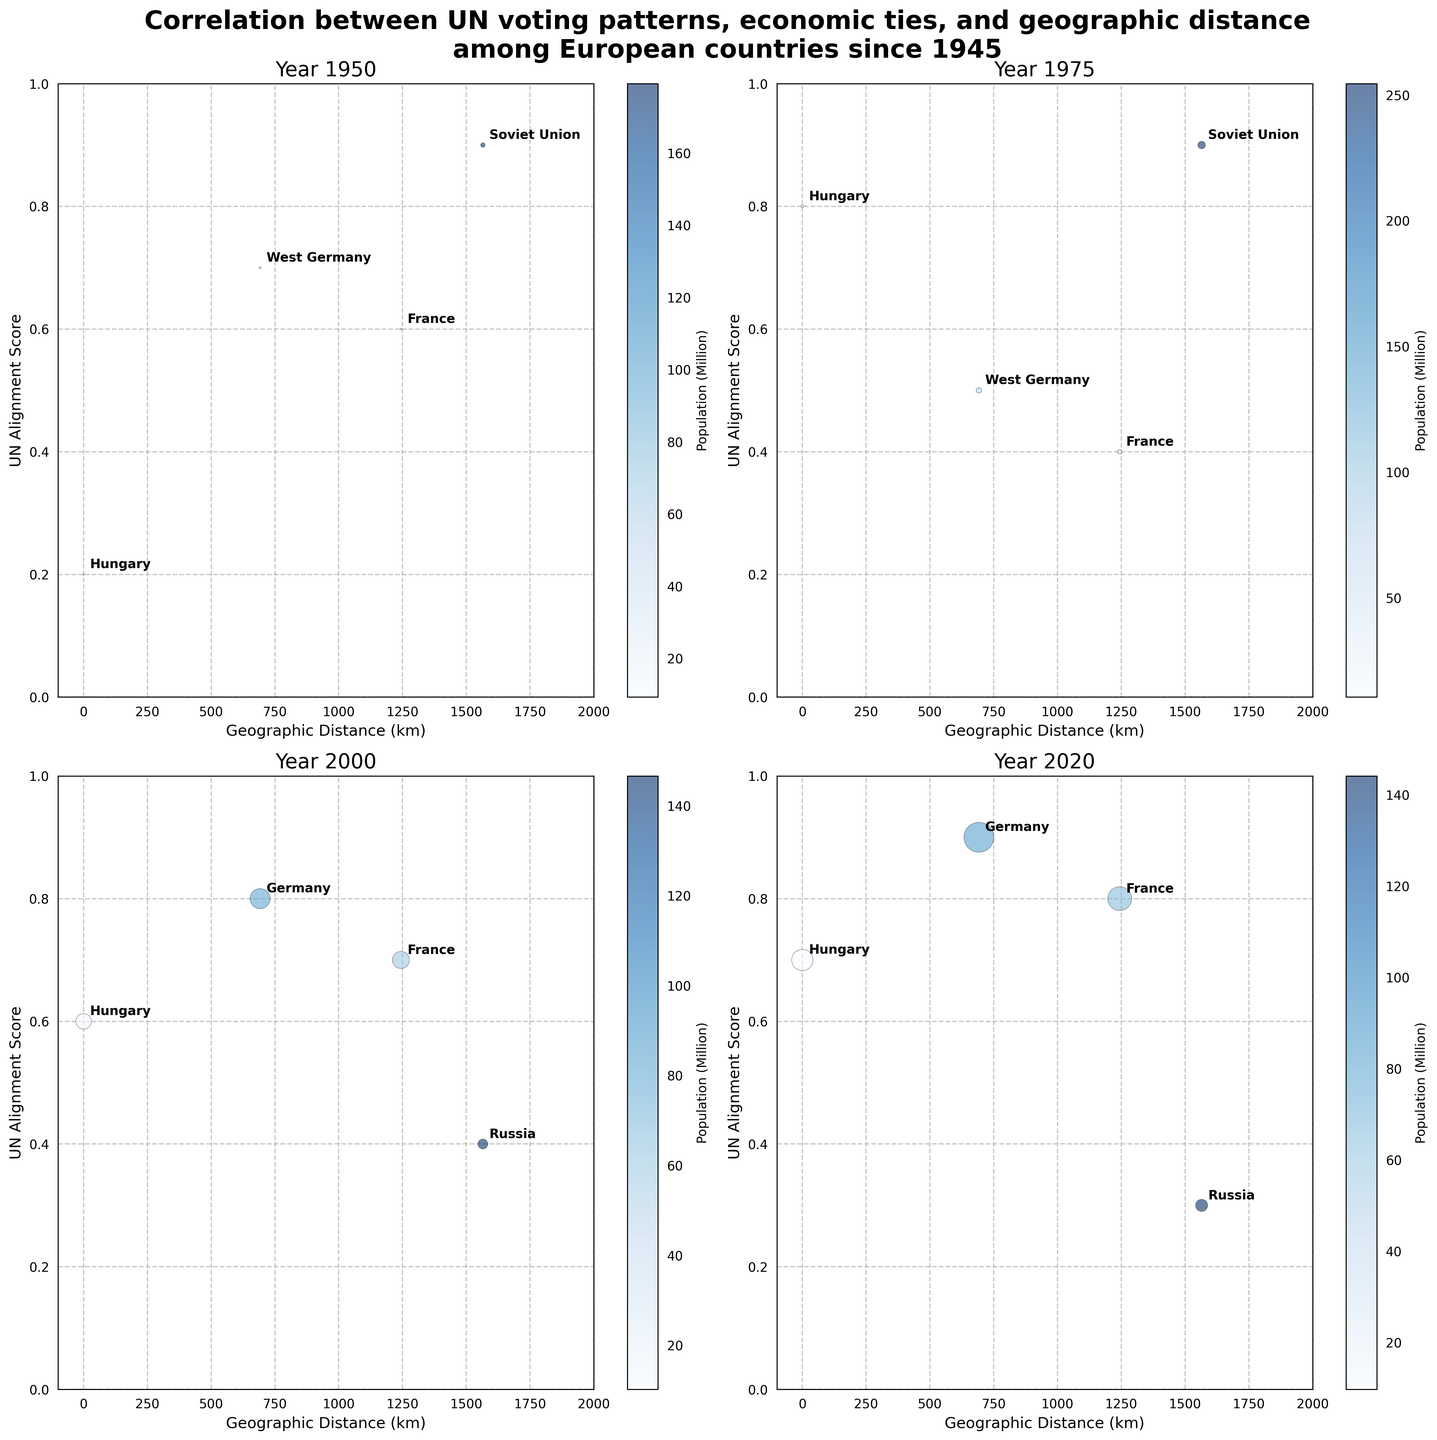Which countries have a geographic distance of 0 km in the year 1950? By observing the subplot for the year 1950, you can identify which countries have markers at the geographic distance of 0 km. In 1950, the country with a distance of 0 km is Hungary.
Answer: Hungary What is the title of the figure? The title is usually prominently displayed at the top of the figure and it describes the overall theme of the plotted data.
Answer: Correlation between UN voting patterns, economic ties, and geographic distance among European countries since 1945 Which year shows the highest UN Alignment Score for Germany? To find the highest UN Alignment Score for Germany, check the subplots for all the years and compare the scores for Germany in each year. In the year 2020, Germany has the highest UN Alignment Score of 0.9.
Answer: 2020 How does the trade volume for France change from 1950 to 2020? Compare the sizes of the bubbles for France in the subplots for the years 1950 and 2020 respectively. In 1950, France has a trade volume of 180 million EUR, and in 2020, a trade volume of 35000 million EUR. The trade volume has increased significantly over this period.
Answer: Increased significantly Which country has the largest bubble in the year 2000? The size of the bubbles represents the trade volume, and the largest bubble indicates the highest trade volume. In the year 2000, Germany has the largest bubble.
Answer: Germany What trend can be observed in the UN Alignment Score of Hungary from 1950 to 2020? Observe the position of Hungary's bubbles in terms of the y-axis across all subplots from 1950 to 2020. In 1950, the score is 0.2, which increases to 0.8 in 1975, decreases slightly to 0.6 in 2000, and increases again to 0.7 in 2020. The overall trend shows fluctuations but generally an increasing alignment.
Answer: Increasing with fluctuations Compare the UN Alignment Scores of France and the Soviet Union/Russia in 1975. Look at the y-axis position of the bubbles for France and the Soviet Union (the predecessor of Russia) in the 1975 subplot. France has a score of 0.4, while the Soviet Union has a score of 0.9. The Soviet Union has a higher score.
Answer: Soviet Union has a higher score Which year has the largest number of countries plotted? Count the number of bubbles in each subplot. The count of countries in each year are: 1950 (4), 1975 (4), 2000 (4), and 2020 (4). Each year has the same number of countries plotted, which is 4.
Answer: Each year has 4 countries plotted What is the general relationship between geographic distance and UN Alignment Score for the countries in 2000? Observe the scatter pattern of the points in the 2000 subplot. The scores (y-axis) do not show a consistent increasing or decreasing trend with geographic distance (x-axis), indicating a weak or non-linear relationship.
Answer: Weak or non-linear relationship 